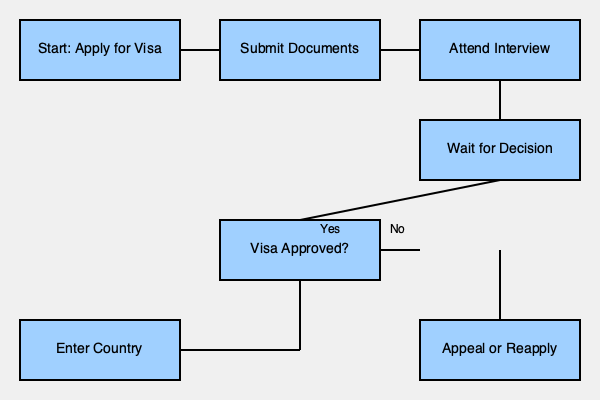According to the flowchart, what is the step immediately after "Wait for Decision" in the immigration process? To answer this question, let's follow the steps in the flowchart:

1. The process starts with "Apply for Visa"
2. It then moves to "Submit Documents"
3. Next is "Attend Interview"
4. After the interview, the applicant must "Wait for Decision"
5. Following the "Wait for Decision" step, there's a decision point: "Visa Approved?"

Therefore, the step immediately after "Wait for Decision" is the decision point "Visa Approved?". This is where the outcome of the visa application is determined, leading to either entering the country (if approved) or appealing/reapplying (if not approved).
Answer: Visa Approved? 